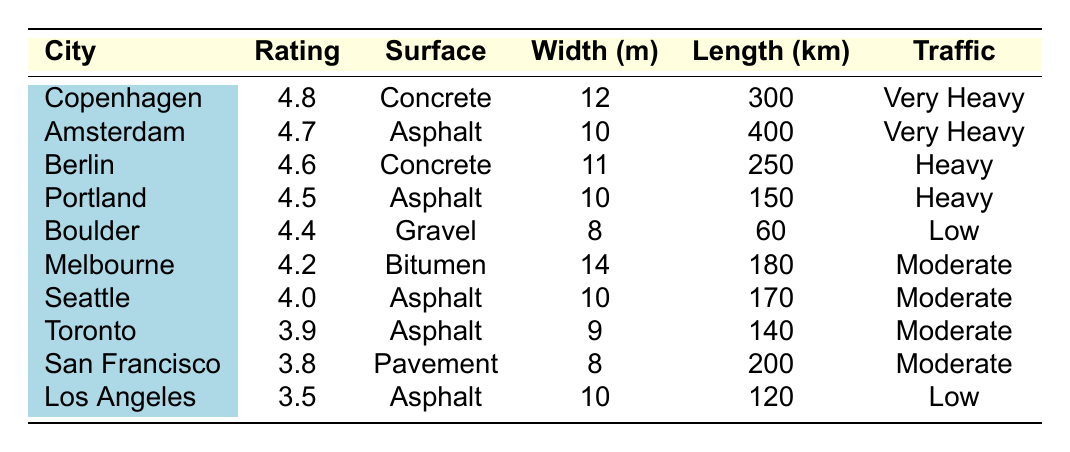What city has the highest bike path quality rating? Looking at the "Rating" column, the highest value is 4.8, which is associated with Copenhagen.
Answer: Copenhagen What is the surface type of the bike path in Amsterdam? The table shows that the surface type for Amsterdam is Asphalt.
Answer: Asphalt Which city has the longest bike path? By comparing the "Length (km)" column, Amsterdam has the longest bike path at 400 km.
Answer: Amsterdam Is the bike traffic in San Francisco classified as heavy? The table states that the bike traffic in San Francisco is classified as Moderate, not Heavy.
Answer: No What is the average bike path rating of cities with "High" maintenance levels? The ratings for high maintenance level cities are 4.5 (Portland), 4.4 (Boulder), and 4.2 (Melbourne). Their sum is 4.5 + 4.4 + 4.2 = 13.1; dividing by 3 gives 13.1 / 3 = 4.366.
Answer: 4.366 Which city has a width of 14 meters? The table reveals that Melbourne has a width of 14 meters.
Answer: Melbourne What is the total length of bike paths for cities with a rating above 4.5? The cities with a rating above 4.5 are Copenhagen (300 km), Amsterdam (400 km), and Berlin (250 km). Summing these gives 300 + 400 + 250 = 950 km.
Answer: 950 km How many cities have "Very Heavy" bike traffic? Checking the "Traffic" column, both Copenhagen and Amsterdam are listed as having "Very Heavy" bike traffic, resulting in 2 cities.
Answer: 2 cities Which city has both the highest rating and the widest bike path? Copenhagen has the highest rating at 4.8 but has a width of 12 meters. The city with the next highest rating, Amsterdam, has a width of 10 meters. Thus, Copenhagen is the only city with the highest rating.
Answer: Copenhagen Does Los Angeles have a higher bike path rating than Seattle? The table states that Los Angeles' rating is 3.5 while Seattle's is 4.0, indicating that Seattle has a higher rating.
Answer: No 